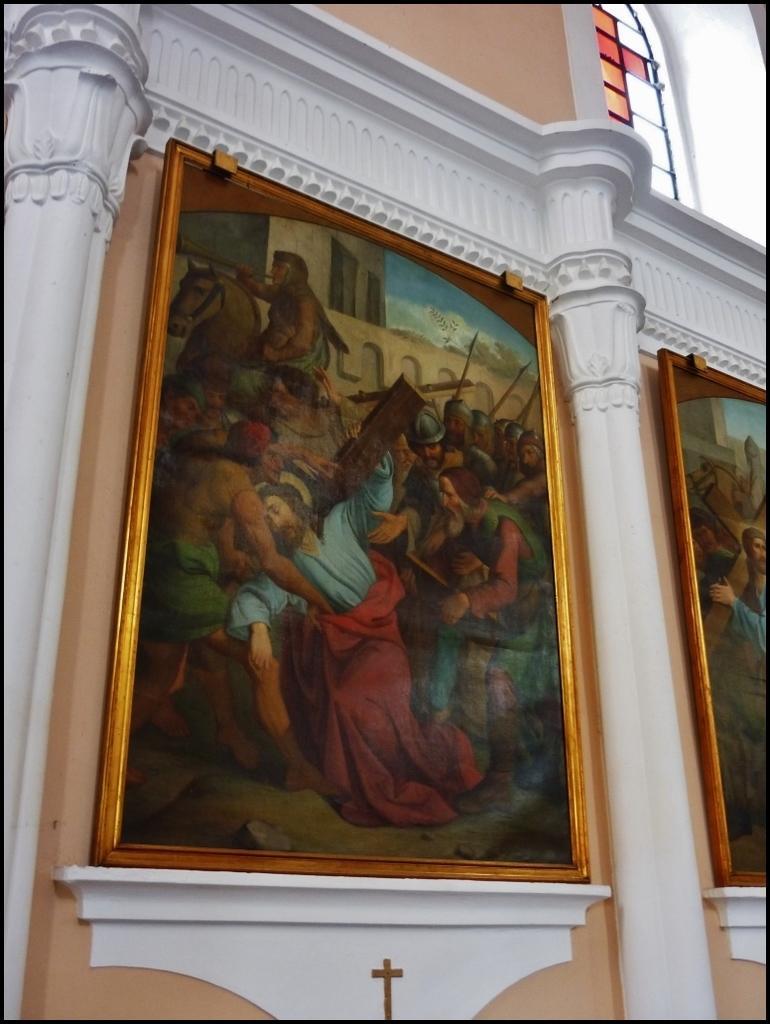How would you summarize this image in a sentence or two? In this image there are pillars and photo frames on the wall. 